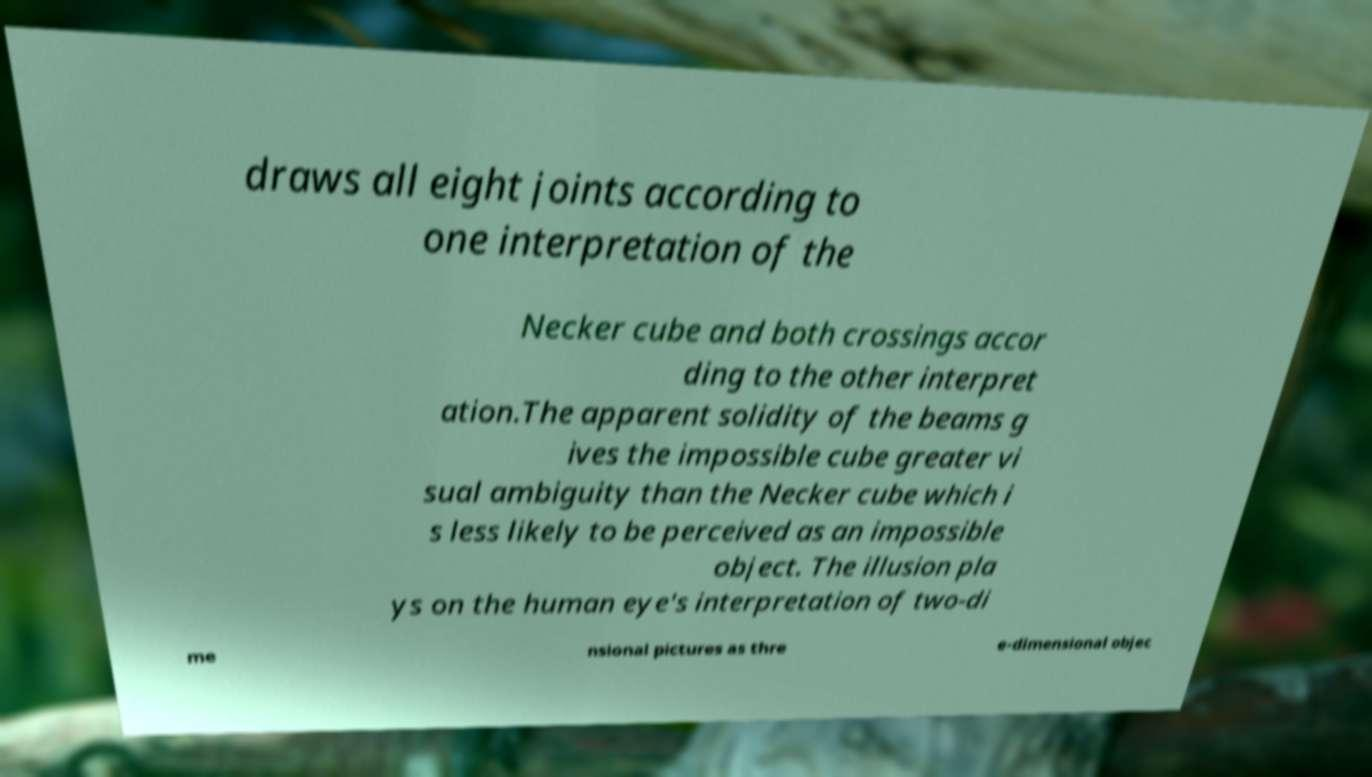What messages or text are displayed in this image? I need them in a readable, typed format. draws all eight joints according to one interpretation of the Necker cube and both crossings accor ding to the other interpret ation.The apparent solidity of the beams g ives the impossible cube greater vi sual ambiguity than the Necker cube which i s less likely to be perceived as an impossible object. The illusion pla ys on the human eye's interpretation of two-di me nsional pictures as thre e-dimensional objec 